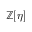Convert formula to latex. <formula><loc_0><loc_0><loc_500><loc_500>\mathbb { Z } [ \eta ]</formula> 